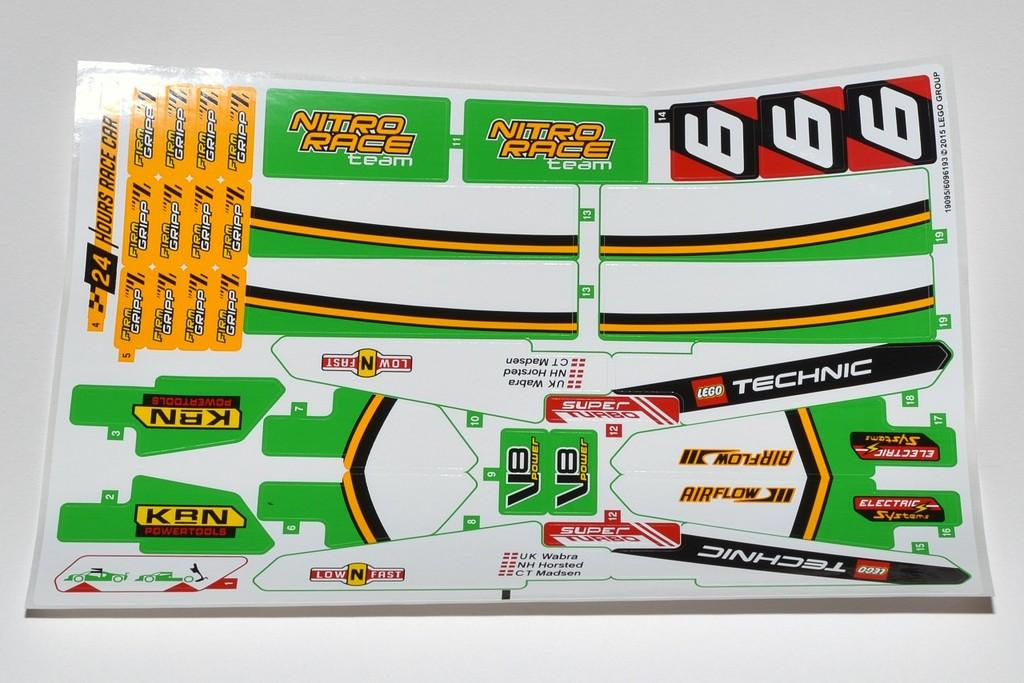Provide a one-sentence caption for the provided image. Race theme stickers with one reading "Nitro Race team". 